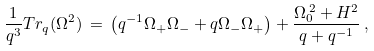Convert formula to latex. <formula><loc_0><loc_0><loc_500><loc_500>\frac { 1 } { q ^ { 3 } } T r _ { q } ( \Omega ^ { 2 } ) \, = \, \left ( q ^ { - 1 } \Omega _ { + } \Omega _ { - } + q \Omega _ { - } \Omega _ { + } \right ) + \frac { \Omega ^ { \, 2 } _ { 0 } + H ^ { 2 } } { q + q ^ { - 1 } } \, ,</formula> 